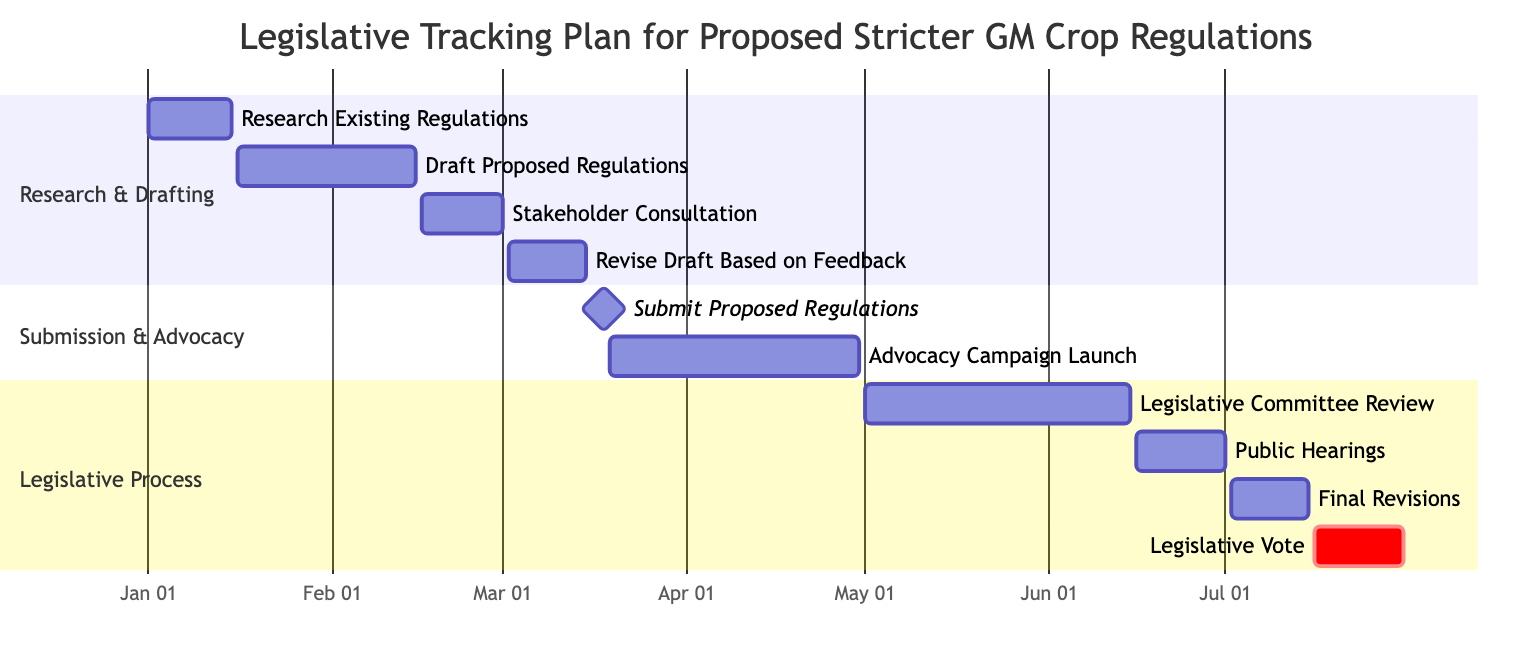What is the duration of the "Research Existing Regulations" task? The "Research Existing Regulations" task starts on January 1, 2024, and ends on January 15, 2024. To find the duration, we calculate the difference between the start and end dates, which is 15 days.
Answer: 15 days How many total tasks are there in the Gantt chart? The Gantt chart lists a total of 10 distinct tasks from "Research Existing Regulations" to "Legislative Vote." I counted each task listed in the chart sections to arrive at the total number.
Answer: 10 What task comes immediately after "Submit Proposed Regulations"? In the Gantt chart structure, after "Submit Proposed Regulations," the next listed task is "Advocacy Campaign Launch." I looked at the sequence of tasks in the Submission & Advocacy section to identify it.
Answer: Advocacy Campaign Launch What is the end date of the "Advocacy Campaign Launch" task? The "Advocacy Campaign Launch" task ends on April 30, 2024, according to the specified date range in the Gantt chart. This information is directly taken from the task details provided in the diagram.
Answer: April 30, 2024 Which task has the longest duration, and how long is it? "Legislative Committee Review" has the longest duration, spanning from May 1, 2024, to June 15, 2024, for a total of 46 days. I determined the duration by calculating the time between the start and end dates for each task and comparing them.
Answer: 46 days What section contains the "Final Revisions" task? The "Final Revisions" task is located in the "Legislative Process" section, as the Gantt chart is organized into different sections, and this task is listed within the specified Legislative Process area.
Answer: Legislative Process How many days are reserved for public hearings? The "Public Hearings" task runs from June 16, 2024, to July 1, 2024. Counting the day range gives a total of 15 days. This can be verified by observing the start and end dates for that task.
Answer: 15 days What is the milestone date in the diagram? The milestone date in the diagram is March 18, 2024, which marks the deadline for submitting proposed regulations. This is indicated as a milestone in the Submission & Advocacy section.
Answer: March 18, 2024 Which task is immediately before the "Legislative Vote"? The task immediately preceding the "Legislative Vote" is "Final Revisions." By reviewing the sequence of tasks in the Legislative Process section, I confirmed the order of completion.
Answer: Final Revisions 